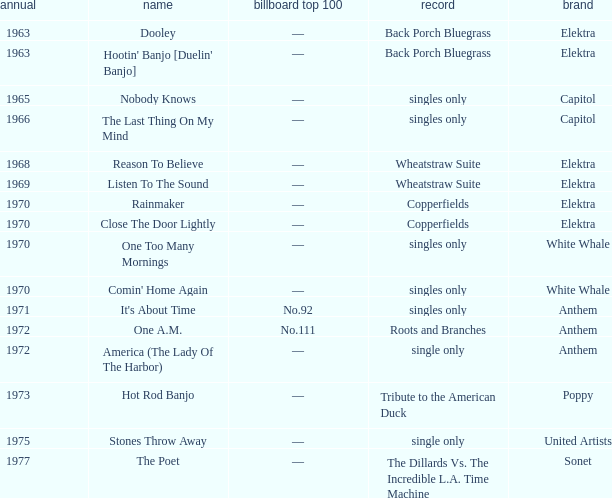What is the total years for roots and branches? 1972.0. I'm looking to parse the entire table for insights. Could you assist me with that? {'header': ['annual', 'name', 'billboard top 100', 'record', 'brand'], 'rows': [['1963', 'Dooley', '—', 'Back Porch Bluegrass', 'Elektra'], ['1963', "Hootin' Banjo [Duelin' Banjo]", '—', 'Back Porch Bluegrass', 'Elektra'], ['1965', 'Nobody Knows', '—', 'singles only', 'Capitol'], ['1966', 'The Last Thing On My Mind', '—', 'singles only', 'Capitol'], ['1968', 'Reason To Believe', '—', 'Wheatstraw Suite', 'Elektra'], ['1969', 'Listen To The Sound', '—', 'Wheatstraw Suite', 'Elektra'], ['1970', 'Rainmaker', '—', 'Copperfields', 'Elektra'], ['1970', 'Close The Door Lightly', '—', 'Copperfields', 'Elektra'], ['1970', 'One Too Many Mornings', '—', 'singles only', 'White Whale'], ['1970', "Comin' Home Again", '—', 'singles only', 'White Whale'], ['1971', "It's About Time", 'No.92', 'singles only', 'Anthem'], ['1972', 'One A.M.', 'No.111', 'Roots and Branches', 'Anthem'], ['1972', 'America (The Lady Of The Harbor)', '—', 'single only', 'Anthem'], ['1973', 'Hot Rod Banjo', '—', 'Tribute to the American Duck', 'Poppy'], ['1975', 'Stones Throw Away', '—', 'single only', 'United Artists'], ['1977', 'The Poet', '—', 'The Dillards Vs. The Incredible L.A. Time Machine', 'Sonet']]} 